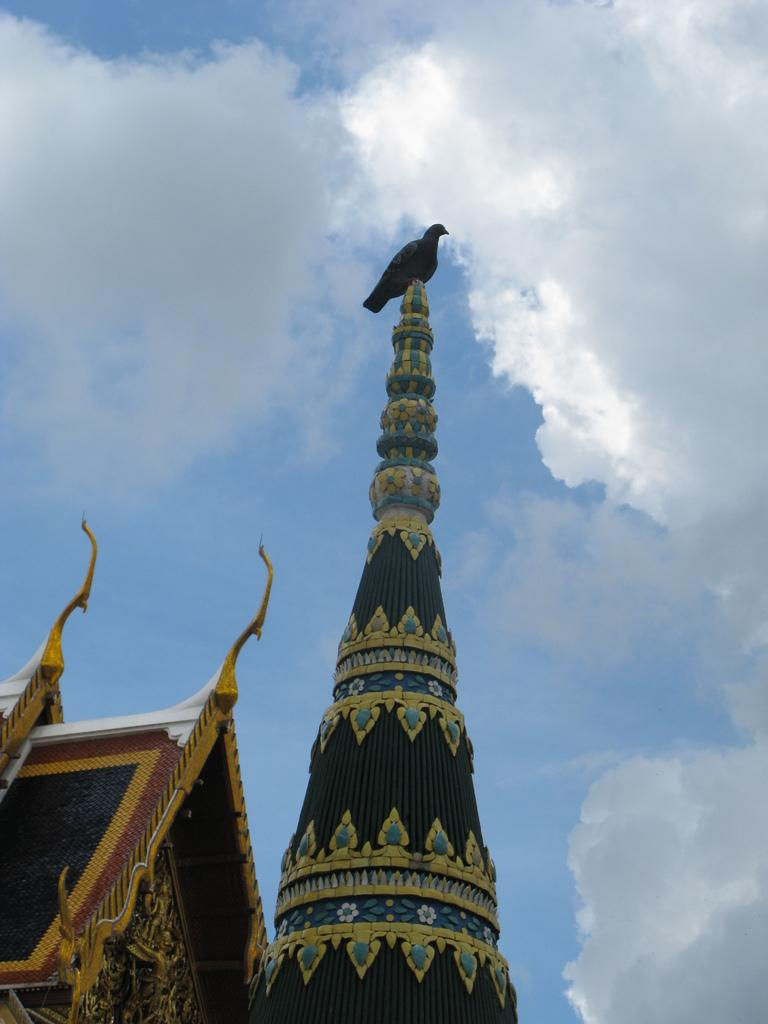What type of bird is in the image? There is a pigeon in the image. Where is the pigeon located? The pigeon is on a tower. What is visible at the top of the image? The sky is visible at the top of the image. Can you see any letters that the pigeon is ashamed of in the image? There are no letters present in the image, and the pigeon is not displaying any emotions such as shame. 